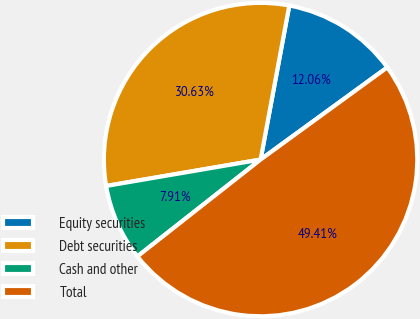<chart> <loc_0><loc_0><loc_500><loc_500><pie_chart><fcel>Equity securities<fcel>Debt securities<fcel>Cash and other<fcel>Total<nl><fcel>12.06%<fcel>30.63%<fcel>7.91%<fcel>49.41%<nl></chart> 